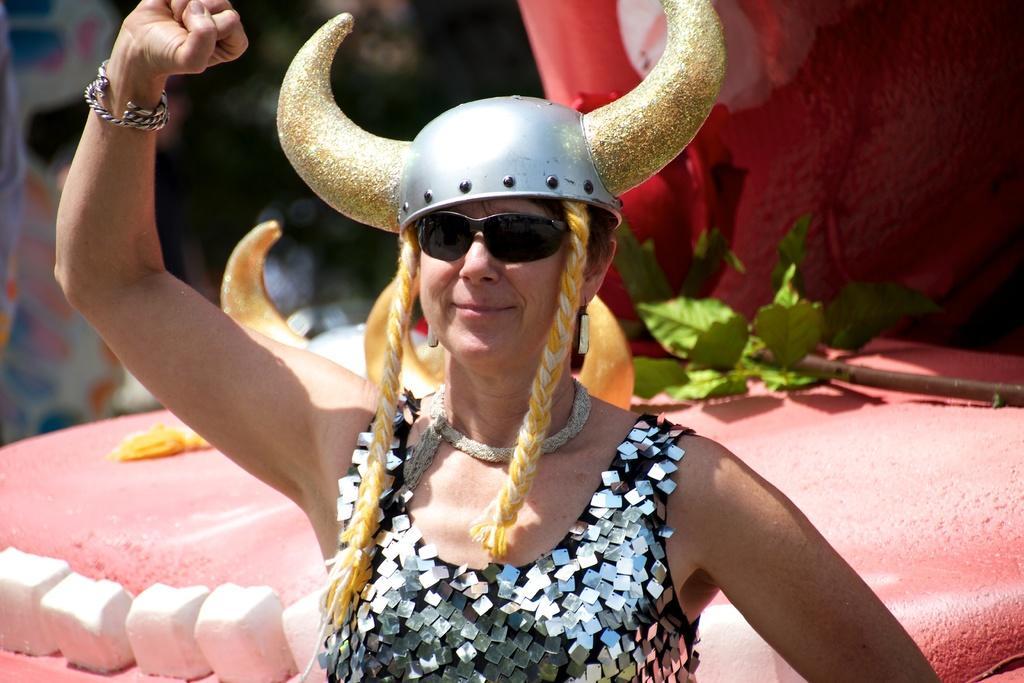Describe this image in one or two sentences. In this image we can see a person wearing sunglasses and a hat and in the background, we can see an object with leaves and some other things. We can see the image in the top left is blurred. 